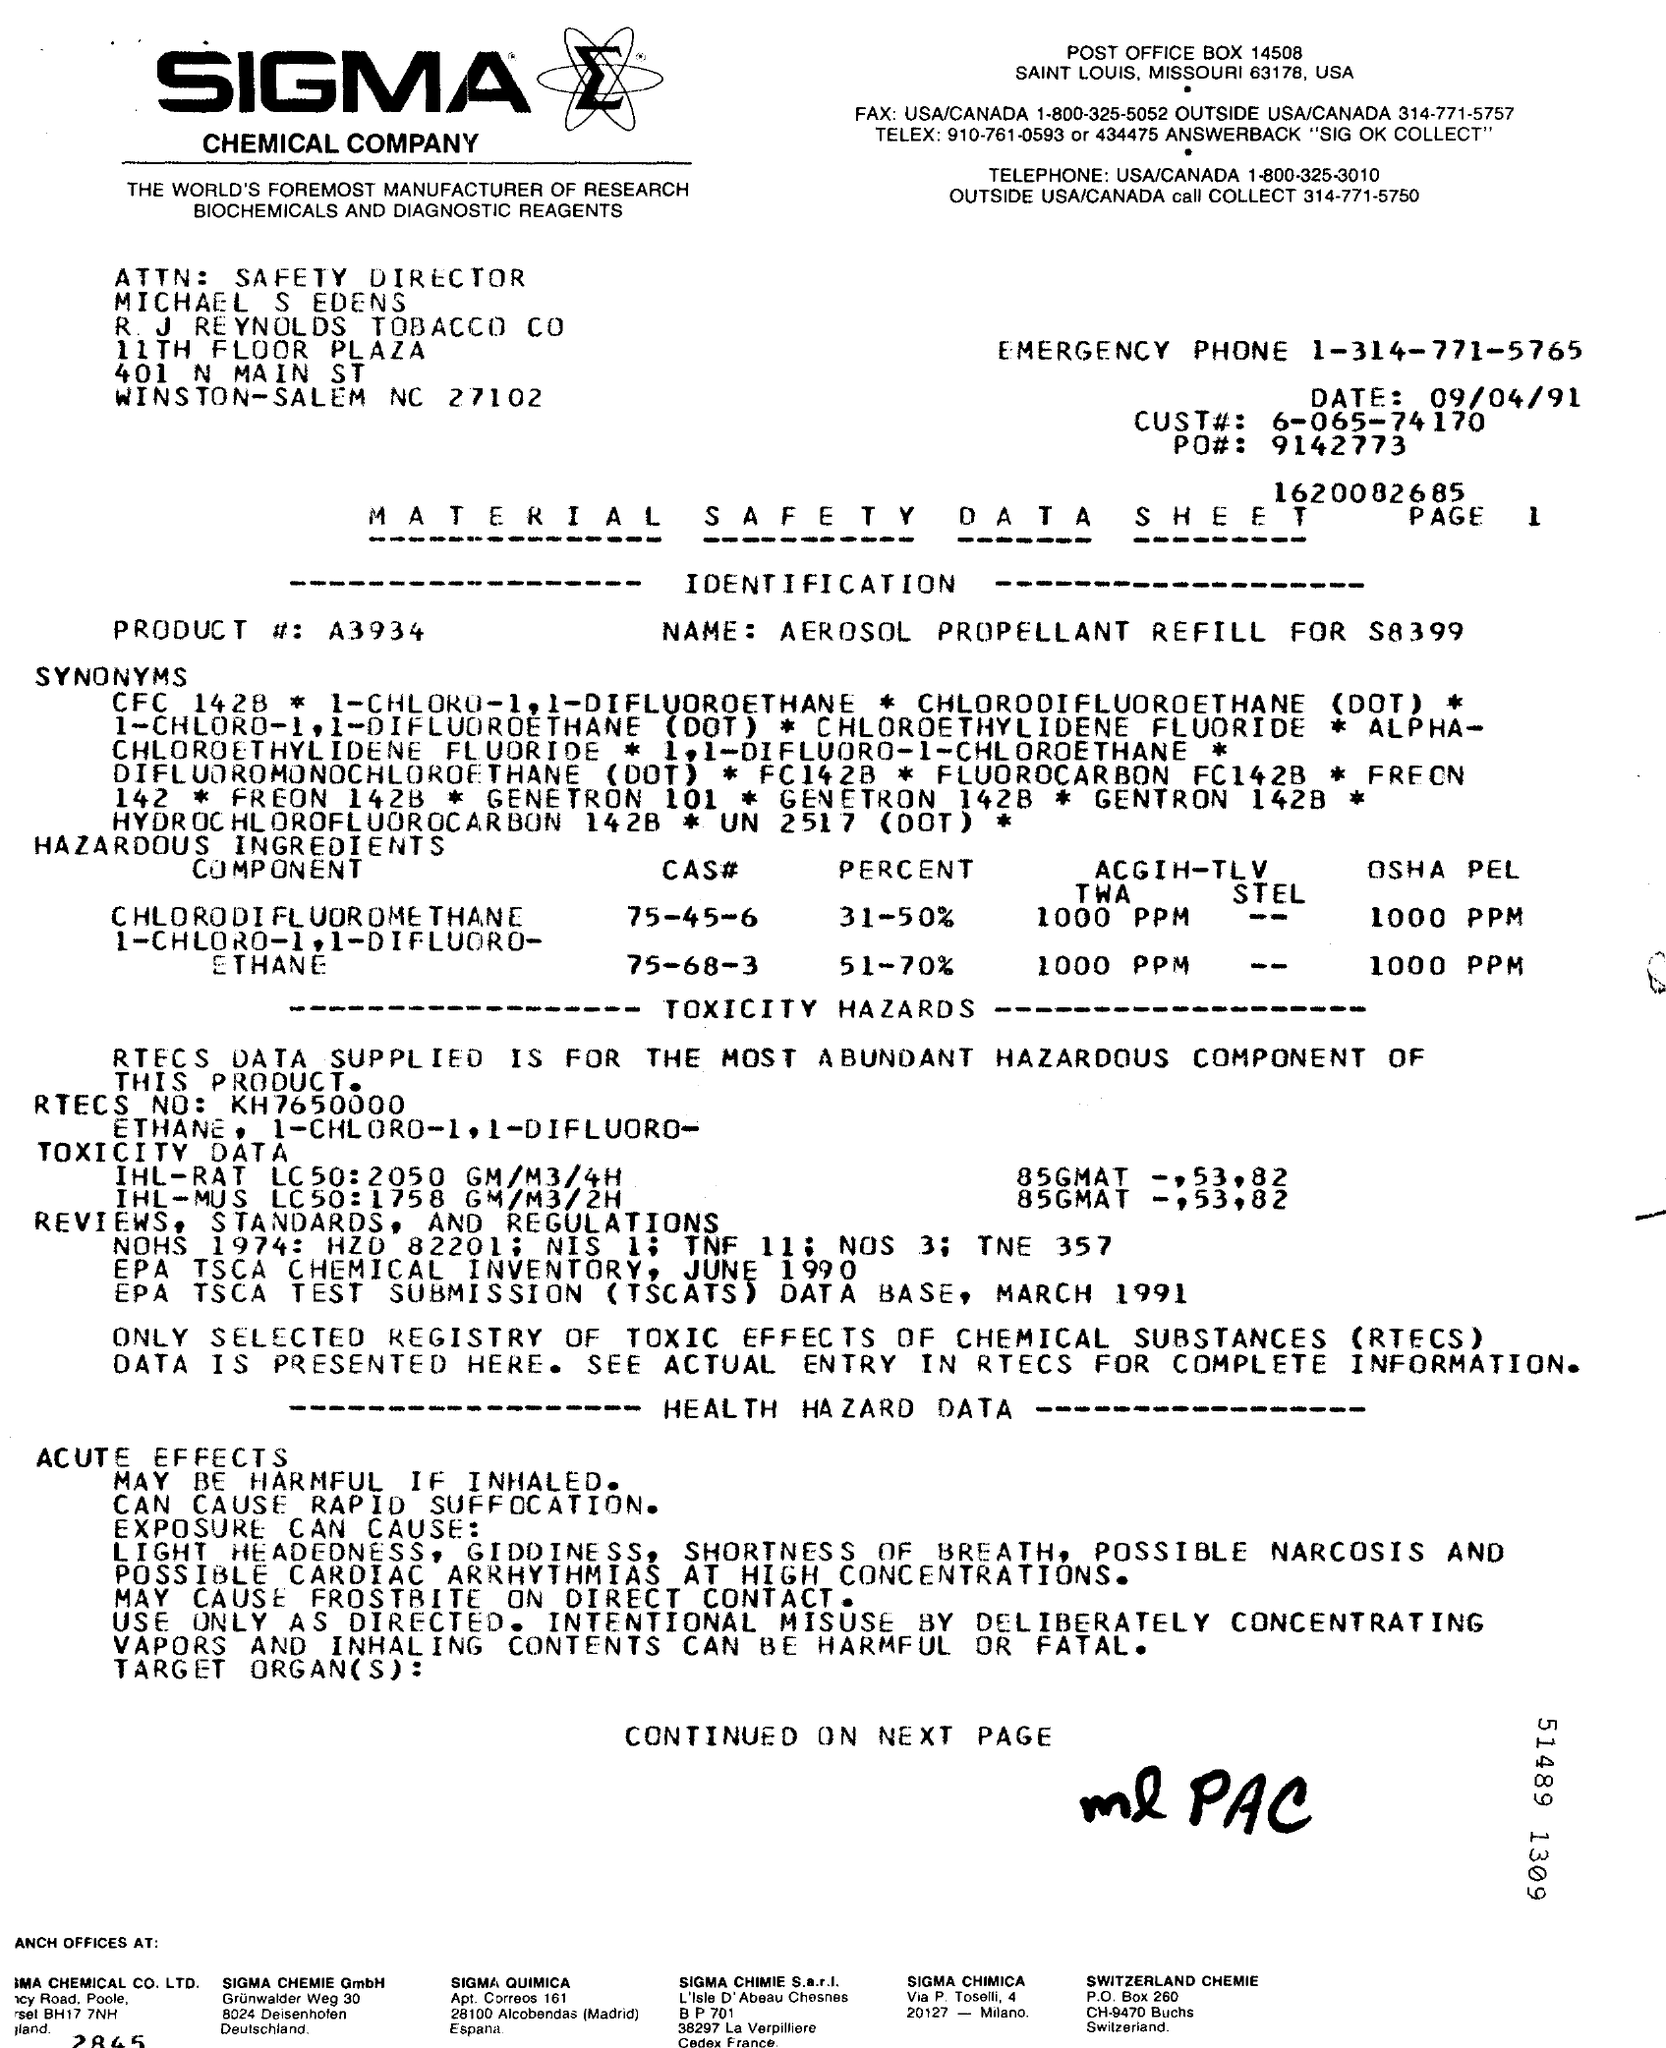What is the name of the chemical company ?
Provide a short and direct response. SIGMA. What is the date mentioned ?
Your response must be concise. 09/04/91. What is the page no mentioned?
Your answer should be compact. 1. What is the emergency phone number ?
Make the answer very short. 1-314-771-5765. What is the cust # number ?
Your response must be concise. 6-065-74170. Who is the safety director of r.j reynolds tobacco co
Provide a succinct answer. Michael S Edens. What is the product # no ?
Your answer should be compact. A3934. What is the name mentioned ?
Ensure brevity in your answer.  AEROSOL PROPELLANT REFILL FOR S8399. What is the post office box no?
Make the answer very short. 14508. What is the fax no for usa/canada ?
Provide a succinct answer. 1-800-325-5052. 